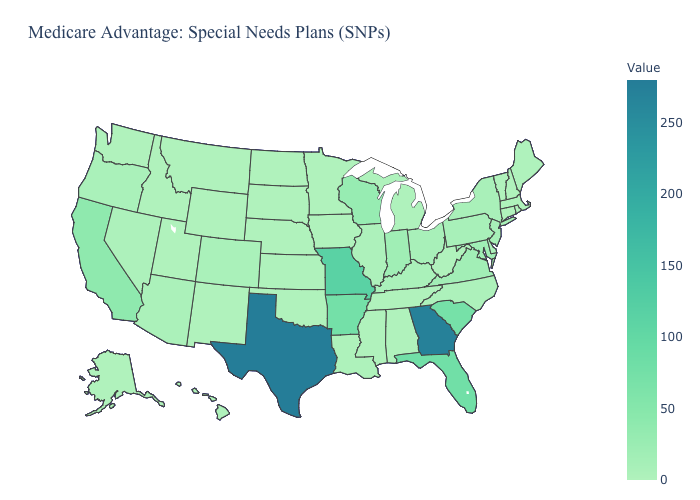Which states have the lowest value in the USA?
Answer briefly. Alaska, Alabama, Connecticut, Hawaii, Iowa, Idaho, Minnesota, Mississippi, Montana, North Dakota, Nebraska, New Hampshire, New Mexico, Oklahoma, Rhode Island, South Dakota, Tennessee, Utah, Vermont, Washington, West Virginia, Wyoming. Which states have the lowest value in the Northeast?
Quick response, please. Connecticut, New Hampshire, Rhode Island, Vermont. Is the legend a continuous bar?
Concise answer only. Yes. Which states have the lowest value in the USA?
Be succinct. Alaska, Alabama, Connecticut, Hawaii, Iowa, Idaho, Minnesota, Mississippi, Montana, North Dakota, Nebraska, New Hampshire, New Mexico, Oklahoma, Rhode Island, South Dakota, Tennessee, Utah, Vermont, Washington, West Virginia, Wyoming. Among the states that border Illinois , does Indiana have the lowest value?
Be succinct. No. Which states hav the highest value in the Northeast?
Keep it brief. New Jersey. Is the legend a continuous bar?
Concise answer only. Yes. 